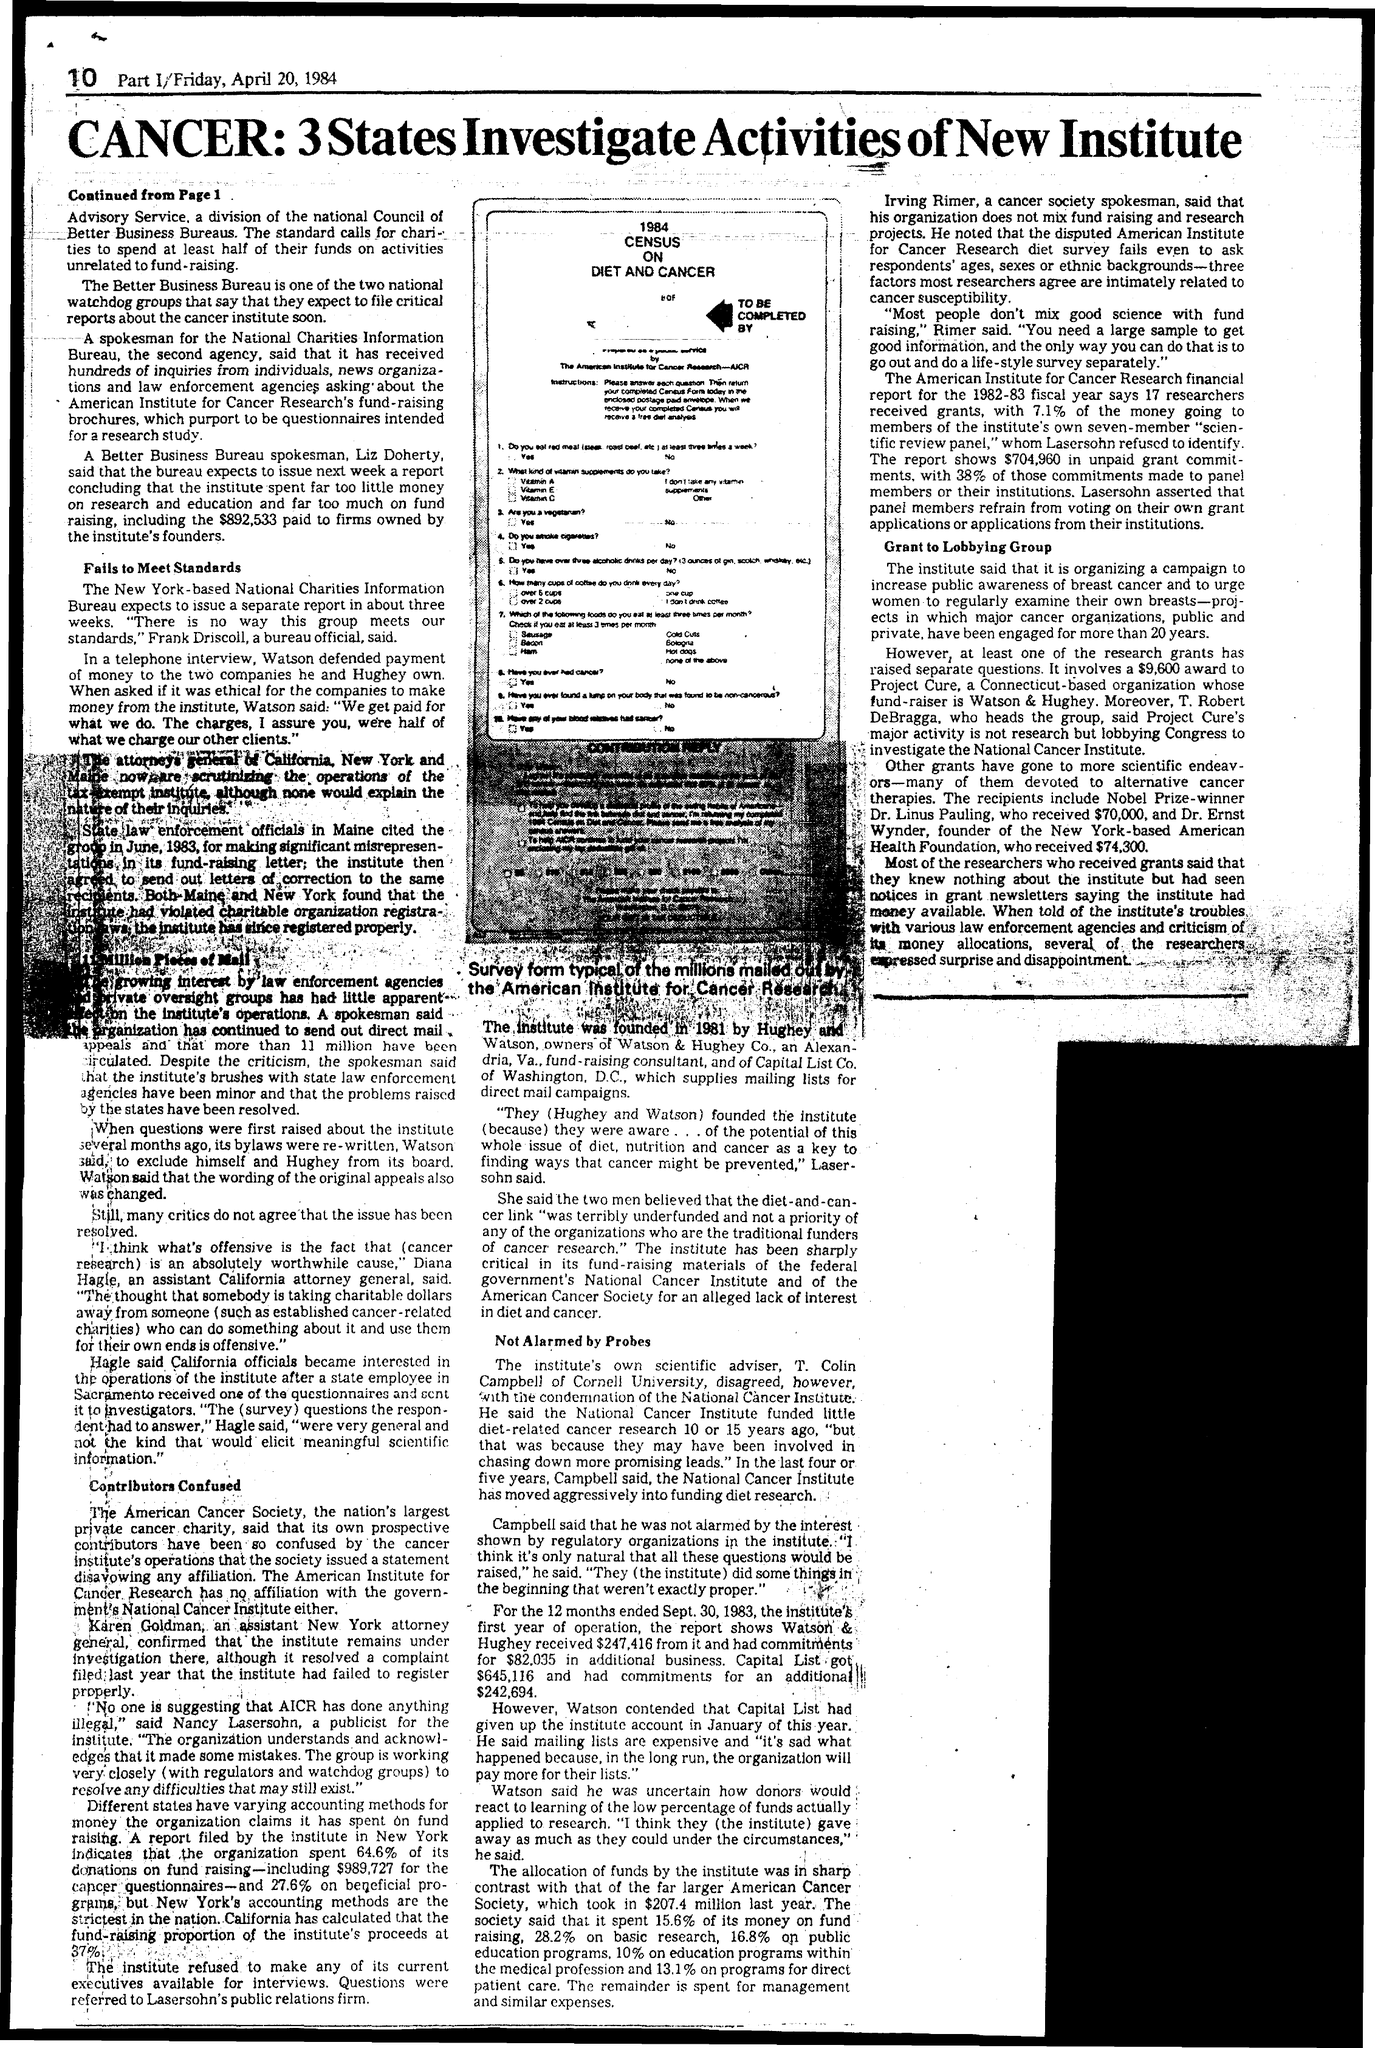The institute was founded in which year
Give a very brief answer. 1981. 